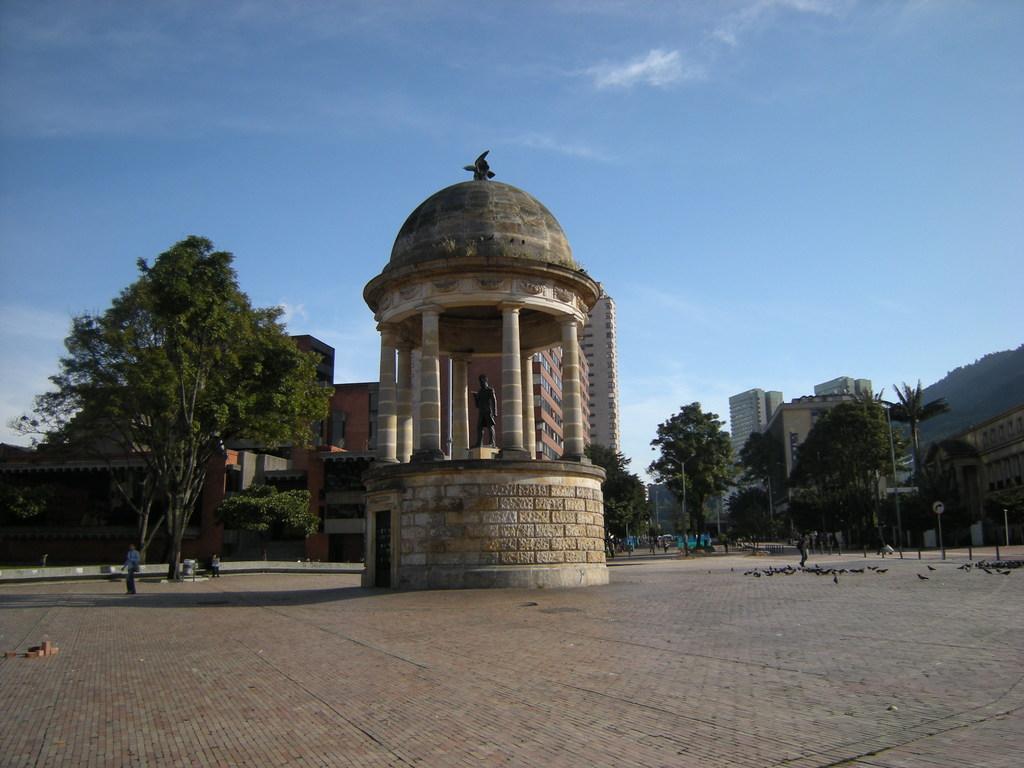Describe this image in one or two sentences. This image consists of a statue in the middle, and there is a small roof along with pillars. At the bottom, there is a road. On the left and right, there are trees. In the background, there are buildings. At the top, there is sky. And we can see many persons walking on the road. On the right, there are birds on the road. 